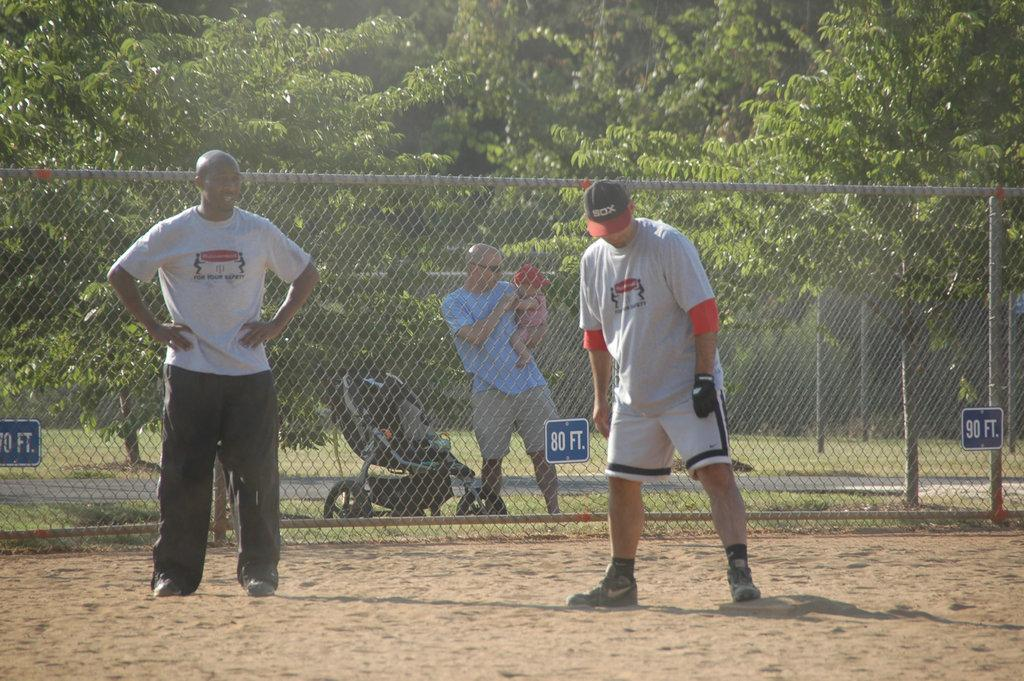<image>
Present a compact description of the photo's key features. Two sportsmen standing on front of a fence with 80ft on it. 